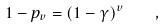Convert formula to latex. <formula><loc_0><loc_0><loc_500><loc_500>1 - p _ { v } = ( 1 - \gamma ) ^ { v } \quad ,</formula> 